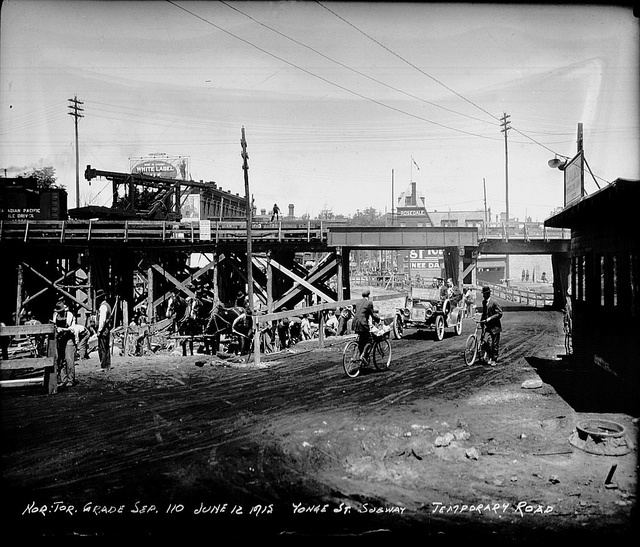Describe the objects in this image and their specific colors. I can see people in black, darkgray, gray, and lightgray tones, car in black, darkgray, gray, and lightgray tones, bench in black, darkgray, gray, and lightgray tones, bicycle in black, gray, darkgray, and lightgray tones, and people in black, gray, darkgray, and lightgray tones in this image. 